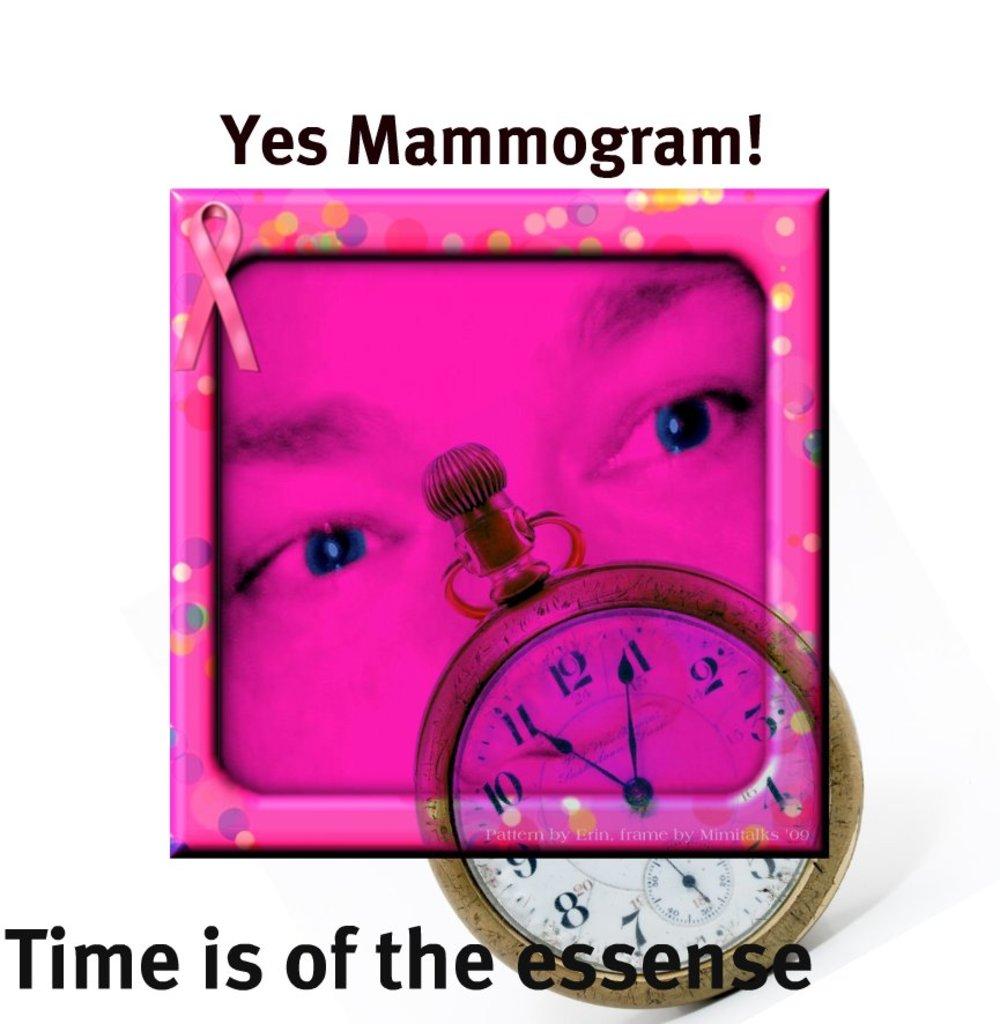What time is it on the pocket watch?
Your answer should be very brief. 11:04. What is of the essence?
Provide a succinct answer. Time. 